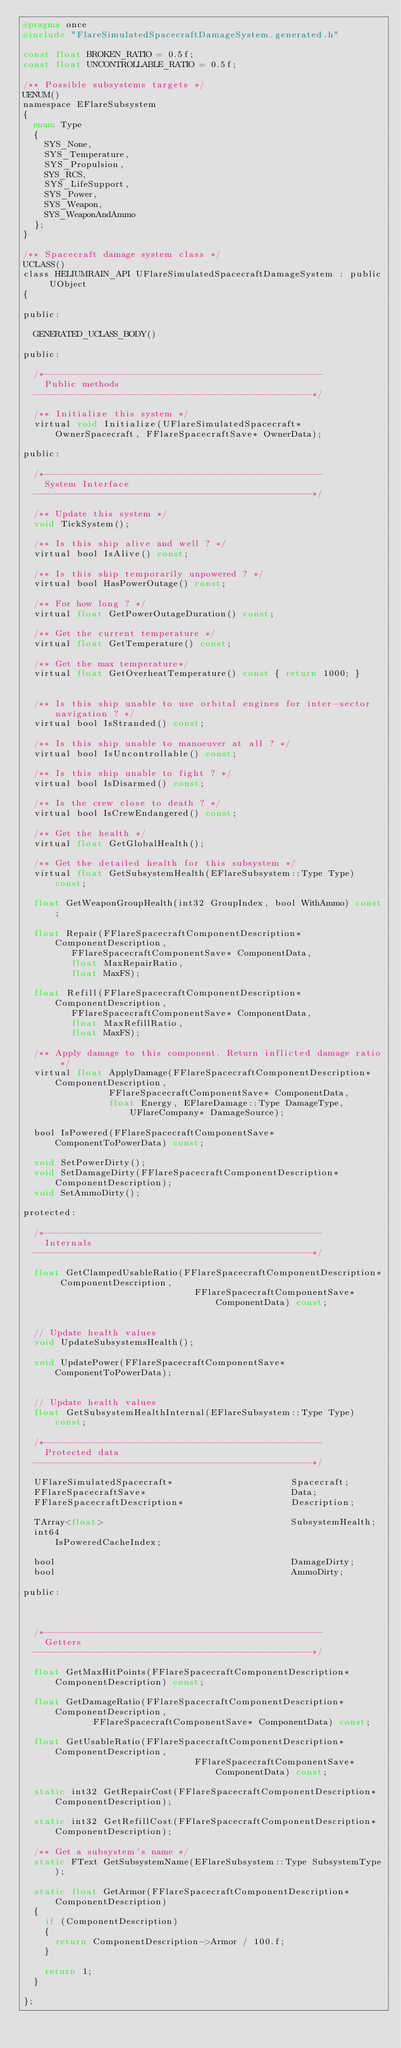<code> <loc_0><loc_0><loc_500><loc_500><_C_>#pragma once
#include "FlareSimulatedSpacecraftDamageSystem.generated.h"

const float BROKEN_RATIO = 0.5f;
const float UNCONTROLLABLE_RATIO = 0.5f;

/** Possible subsystems targets */
UENUM()
namespace EFlareSubsystem
{
	enum Type
	{
		SYS_None,
		SYS_Temperature,
		SYS_Propulsion,
		SYS_RCS,
		SYS_LifeSupport,
		SYS_Power,
		SYS_Weapon,
		SYS_WeaponAndAmmo
	};
}

/** Spacecraft damage system class */
UCLASS()
class HELIUMRAIN_API UFlareSimulatedSpacecraftDamageSystem : public UObject
{

public:

	GENERATED_UCLASS_BODY()

public:

	/*----------------------------------------------------
		Public methods
	----------------------------------------------------*/

	/** Initialize this system */
	virtual void Initialize(UFlareSimulatedSpacecraft* OwnerSpacecraft, FFlareSpacecraftSave* OwnerData);

public:

	/*----------------------------------------------------
		System Interface
	----------------------------------------------------*/

	/** Update this system */
	void TickSystem();

	/** Is this ship alive and well ? */
	virtual bool IsAlive() const;

	/** Is this ship temporarily unpowered ? */
	virtual bool HasPowerOutage() const;

	/** For how long ? */
	virtual float GetPowerOutageDuration() const;

	/** Get the current temperature */
	virtual float GetTemperature() const;

	/** Get the max temperature*/
	virtual float GetOverheatTemperature() const { return 1000; }


	/** Is this ship unable to use orbital engines for inter-sector navigation ? */
	virtual bool IsStranded() const;

	/** Is this ship unable to manoeuver at all ? */
	virtual bool IsUncontrollable() const;

	/** Is this ship unable to fight ? */
	virtual bool IsDisarmed() const;

	/** Is the crew close to death ? */
	virtual bool IsCrewEndangered() const;

	/** Get the health */
	virtual float GetGlobalHealth();

	/** Get the detailed health for this subsystem */
	virtual float GetSubsystemHealth(EFlareSubsystem::Type Type) const;

	float GetWeaponGroupHealth(int32 GroupIndex, bool WithAmmo) const;

	float Repair(FFlareSpacecraftComponentDescription* ComponentDescription,
				 FFlareSpacecraftComponentSave* ComponentData,
				 float MaxRepairRatio,
				 float MaxFS);

	float Refill(FFlareSpacecraftComponentDescription* ComponentDescription,
				 FFlareSpacecraftComponentSave* ComponentData,
				 float MaxRefillRatio,
				 float MaxFS);

	/** Apply damage to this component. Return inflicted damage ratio */
	virtual float ApplyDamage(FFlareSpacecraftComponentDescription* ComponentDescription,
							  FFlareSpacecraftComponentSave* ComponentData,
							  float Energy, EFlareDamage::Type DamageType, UFlareCompany* DamageSource);
	
	bool IsPowered(FFlareSpacecraftComponentSave* ComponentToPowerData) const;

	void SetPowerDirty();
	void SetDamageDirty(FFlareSpacecraftComponentDescription* ComponentDescription);
	void SetAmmoDirty();

protected:

	/*----------------------------------------------------
		Internals
	----------------------------------------------------*/

	float GetClampedUsableRatio(FFlareSpacecraftComponentDescription* ComponentDescription,
																FFlareSpacecraftComponentSave* ComponentData) const;


	// Update health values
	void UpdateSubsystemsHealth();

	void UpdatePower(FFlareSpacecraftComponentSave* ComponentToPowerData);


	// Update health values
	float GetSubsystemHealthInternal(EFlareSubsystem::Type Type) const;

	/*----------------------------------------------------
		Protected data
	----------------------------------------------------*/

	UFlareSimulatedSpacecraft*                      Spacecraft;
	FFlareSpacecraftSave*                           Data;
	FFlareSpacecraftDescription*                    Description;

	TArray<float>                                   SubsystemHealth;
	int64                                           IsPoweredCacheIndex;

	bool                                            DamageDirty;
	bool                                            AmmoDirty;

public:



	/*----------------------------------------------------
		Getters
	----------------------------------------------------*/

	float GetMaxHitPoints(FFlareSpacecraftComponentDescription* ComponentDescription) const;

	float GetDamageRatio(FFlareSpacecraftComponentDescription* ComponentDescription,
						 FFlareSpacecraftComponentSave* ComponentData) const;

	float GetUsableRatio(FFlareSpacecraftComponentDescription* ComponentDescription,
																FFlareSpacecraftComponentSave* ComponentData) const;

	static int32 GetRepairCost(FFlareSpacecraftComponentDescription* ComponentDescription);

	static int32 GetRefillCost(FFlareSpacecraftComponentDescription* ComponentDescription);

	/** Get a subsystem's name */
	static FText GetSubsystemName(EFlareSubsystem::Type SubsystemType);

	static float GetArmor(FFlareSpacecraftComponentDescription* ComponentDescription)
	{
		if (ComponentDescription)
		{
			return ComponentDescription->Armor / 100.f;
		}

		return 1;
	}

};
</code> 